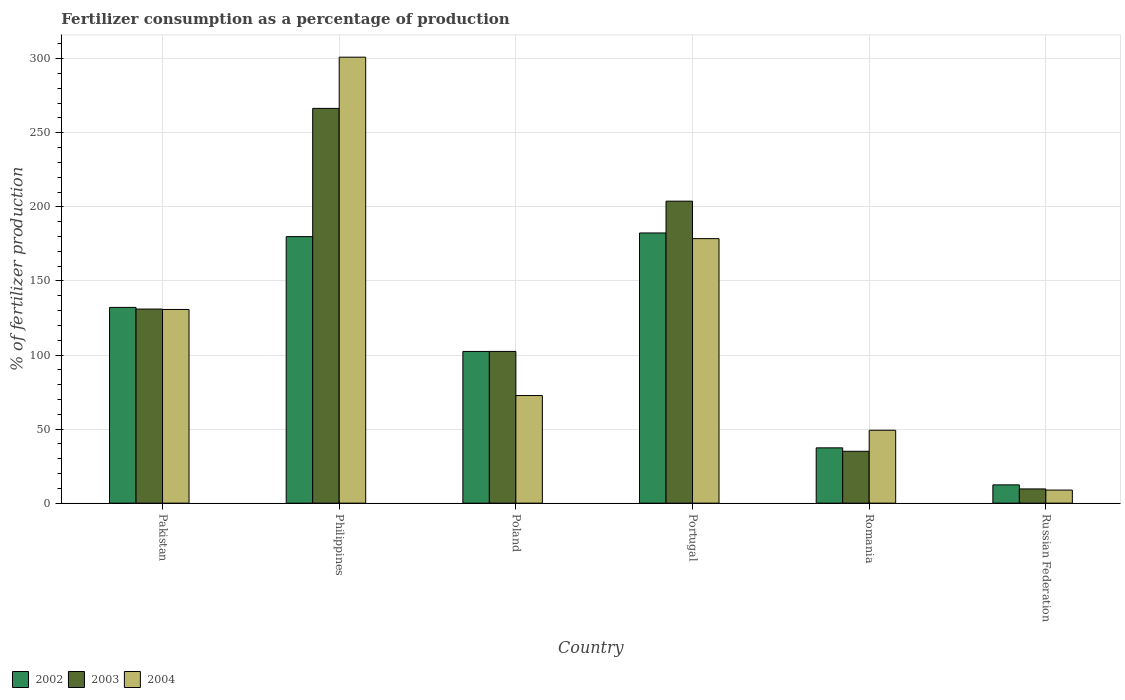How many different coloured bars are there?
Make the answer very short. 3. How many groups of bars are there?
Provide a succinct answer. 6. Are the number of bars per tick equal to the number of legend labels?
Your answer should be compact. Yes. How many bars are there on the 4th tick from the right?
Offer a terse response. 3. What is the label of the 6th group of bars from the left?
Make the answer very short. Russian Federation. What is the percentage of fertilizers consumed in 2002 in Poland?
Your answer should be very brief. 102.4. Across all countries, what is the maximum percentage of fertilizers consumed in 2002?
Keep it short and to the point. 182.38. Across all countries, what is the minimum percentage of fertilizers consumed in 2004?
Provide a short and direct response. 8.83. In which country was the percentage of fertilizers consumed in 2003 maximum?
Provide a short and direct response. Philippines. In which country was the percentage of fertilizers consumed in 2003 minimum?
Your response must be concise. Russian Federation. What is the total percentage of fertilizers consumed in 2004 in the graph?
Give a very brief answer. 740.99. What is the difference between the percentage of fertilizers consumed in 2003 in Pakistan and that in Romania?
Offer a very short reply. 96.01. What is the difference between the percentage of fertilizers consumed in 2002 in Philippines and the percentage of fertilizers consumed in 2004 in Romania?
Your answer should be compact. 130.7. What is the average percentage of fertilizers consumed in 2004 per country?
Provide a short and direct response. 123.5. What is the difference between the percentage of fertilizers consumed of/in 2002 and percentage of fertilizers consumed of/in 2003 in Russian Federation?
Provide a succinct answer. 2.74. What is the ratio of the percentage of fertilizers consumed in 2003 in Philippines to that in Romania?
Keep it short and to the point. 7.61. Is the difference between the percentage of fertilizers consumed in 2002 in Philippines and Russian Federation greater than the difference between the percentage of fertilizers consumed in 2003 in Philippines and Russian Federation?
Make the answer very short. No. What is the difference between the highest and the second highest percentage of fertilizers consumed in 2003?
Provide a short and direct response. 62.63. What is the difference between the highest and the lowest percentage of fertilizers consumed in 2004?
Provide a succinct answer. 292.21. In how many countries, is the percentage of fertilizers consumed in 2002 greater than the average percentage of fertilizers consumed in 2002 taken over all countries?
Your answer should be very brief. 3. Is it the case that in every country, the sum of the percentage of fertilizers consumed in 2003 and percentage of fertilizers consumed in 2002 is greater than the percentage of fertilizers consumed in 2004?
Provide a short and direct response. Yes. What is the difference between two consecutive major ticks on the Y-axis?
Offer a very short reply. 50. Are the values on the major ticks of Y-axis written in scientific E-notation?
Offer a very short reply. No. Where does the legend appear in the graph?
Make the answer very short. Bottom left. How many legend labels are there?
Make the answer very short. 3. How are the legend labels stacked?
Your answer should be very brief. Horizontal. What is the title of the graph?
Offer a very short reply. Fertilizer consumption as a percentage of production. Does "1965" appear as one of the legend labels in the graph?
Make the answer very short. No. What is the label or title of the Y-axis?
Provide a short and direct response. % of fertilizer production. What is the % of fertilizer production in 2002 in Pakistan?
Provide a short and direct response. 132.13. What is the % of fertilizer production of 2003 in Pakistan?
Give a very brief answer. 131.01. What is the % of fertilizer production of 2004 in Pakistan?
Give a very brief answer. 130.73. What is the % of fertilizer production of 2002 in Philippines?
Your response must be concise. 179.9. What is the % of fertilizer production in 2003 in Philippines?
Your answer should be very brief. 266.48. What is the % of fertilizer production of 2004 in Philippines?
Ensure brevity in your answer.  301.04. What is the % of fertilizer production in 2002 in Poland?
Offer a very short reply. 102.4. What is the % of fertilizer production of 2003 in Poland?
Your answer should be very brief. 102.42. What is the % of fertilizer production in 2004 in Poland?
Provide a short and direct response. 72.64. What is the % of fertilizer production in 2002 in Portugal?
Your answer should be very brief. 182.38. What is the % of fertilizer production in 2003 in Portugal?
Provide a short and direct response. 203.85. What is the % of fertilizer production of 2004 in Portugal?
Provide a short and direct response. 178.55. What is the % of fertilizer production of 2002 in Romania?
Offer a very short reply. 37.32. What is the % of fertilizer production in 2003 in Romania?
Ensure brevity in your answer.  35. What is the % of fertilizer production of 2004 in Romania?
Provide a succinct answer. 49.2. What is the % of fertilizer production of 2002 in Russian Federation?
Provide a short and direct response. 12.34. What is the % of fertilizer production of 2003 in Russian Federation?
Give a very brief answer. 9.6. What is the % of fertilizer production of 2004 in Russian Federation?
Offer a very short reply. 8.83. Across all countries, what is the maximum % of fertilizer production of 2002?
Your answer should be very brief. 182.38. Across all countries, what is the maximum % of fertilizer production in 2003?
Your answer should be very brief. 266.48. Across all countries, what is the maximum % of fertilizer production of 2004?
Your response must be concise. 301.04. Across all countries, what is the minimum % of fertilizer production of 2002?
Your response must be concise. 12.34. Across all countries, what is the minimum % of fertilizer production of 2003?
Your response must be concise. 9.6. Across all countries, what is the minimum % of fertilizer production of 2004?
Keep it short and to the point. 8.83. What is the total % of fertilizer production in 2002 in the graph?
Keep it short and to the point. 646.47. What is the total % of fertilizer production in 2003 in the graph?
Your answer should be very brief. 748.35. What is the total % of fertilizer production of 2004 in the graph?
Make the answer very short. 740.99. What is the difference between the % of fertilizer production in 2002 in Pakistan and that in Philippines?
Offer a very short reply. -47.77. What is the difference between the % of fertilizer production of 2003 in Pakistan and that in Philippines?
Your answer should be compact. -135.47. What is the difference between the % of fertilizer production in 2004 in Pakistan and that in Philippines?
Offer a very short reply. -170.31. What is the difference between the % of fertilizer production in 2002 in Pakistan and that in Poland?
Your answer should be very brief. 29.73. What is the difference between the % of fertilizer production of 2003 in Pakistan and that in Poland?
Ensure brevity in your answer.  28.59. What is the difference between the % of fertilizer production in 2004 in Pakistan and that in Poland?
Keep it short and to the point. 58.1. What is the difference between the % of fertilizer production in 2002 in Pakistan and that in Portugal?
Give a very brief answer. -50.24. What is the difference between the % of fertilizer production in 2003 in Pakistan and that in Portugal?
Ensure brevity in your answer.  -72.84. What is the difference between the % of fertilizer production of 2004 in Pakistan and that in Portugal?
Keep it short and to the point. -47.82. What is the difference between the % of fertilizer production in 2002 in Pakistan and that in Romania?
Your response must be concise. 94.81. What is the difference between the % of fertilizer production of 2003 in Pakistan and that in Romania?
Your answer should be very brief. 96.01. What is the difference between the % of fertilizer production in 2004 in Pakistan and that in Romania?
Your response must be concise. 81.54. What is the difference between the % of fertilizer production in 2002 in Pakistan and that in Russian Federation?
Your answer should be compact. 119.79. What is the difference between the % of fertilizer production in 2003 in Pakistan and that in Russian Federation?
Make the answer very short. 121.41. What is the difference between the % of fertilizer production in 2004 in Pakistan and that in Russian Federation?
Your answer should be very brief. 121.91. What is the difference between the % of fertilizer production of 2002 in Philippines and that in Poland?
Provide a succinct answer. 77.5. What is the difference between the % of fertilizer production of 2003 in Philippines and that in Poland?
Make the answer very short. 164.06. What is the difference between the % of fertilizer production in 2004 in Philippines and that in Poland?
Keep it short and to the point. 228.4. What is the difference between the % of fertilizer production of 2002 in Philippines and that in Portugal?
Your response must be concise. -2.48. What is the difference between the % of fertilizer production of 2003 in Philippines and that in Portugal?
Your response must be concise. 62.63. What is the difference between the % of fertilizer production of 2004 in Philippines and that in Portugal?
Keep it short and to the point. 122.49. What is the difference between the % of fertilizer production in 2002 in Philippines and that in Romania?
Give a very brief answer. 142.58. What is the difference between the % of fertilizer production of 2003 in Philippines and that in Romania?
Your response must be concise. 231.48. What is the difference between the % of fertilizer production of 2004 in Philippines and that in Romania?
Keep it short and to the point. 251.84. What is the difference between the % of fertilizer production of 2002 in Philippines and that in Russian Federation?
Make the answer very short. 167.56. What is the difference between the % of fertilizer production in 2003 in Philippines and that in Russian Federation?
Offer a terse response. 256.88. What is the difference between the % of fertilizer production in 2004 in Philippines and that in Russian Federation?
Provide a short and direct response. 292.21. What is the difference between the % of fertilizer production in 2002 in Poland and that in Portugal?
Provide a succinct answer. -79.97. What is the difference between the % of fertilizer production of 2003 in Poland and that in Portugal?
Your response must be concise. -101.43. What is the difference between the % of fertilizer production of 2004 in Poland and that in Portugal?
Provide a short and direct response. -105.91. What is the difference between the % of fertilizer production of 2002 in Poland and that in Romania?
Make the answer very short. 65.08. What is the difference between the % of fertilizer production in 2003 in Poland and that in Romania?
Offer a very short reply. 67.42. What is the difference between the % of fertilizer production in 2004 in Poland and that in Romania?
Keep it short and to the point. 23.44. What is the difference between the % of fertilizer production of 2002 in Poland and that in Russian Federation?
Provide a succinct answer. 90.06. What is the difference between the % of fertilizer production of 2003 in Poland and that in Russian Federation?
Your answer should be very brief. 92.82. What is the difference between the % of fertilizer production of 2004 in Poland and that in Russian Federation?
Your answer should be very brief. 63.81. What is the difference between the % of fertilizer production of 2002 in Portugal and that in Romania?
Keep it short and to the point. 145.06. What is the difference between the % of fertilizer production in 2003 in Portugal and that in Romania?
Ensure brevity in your answer.  168.85. What is the difference between the % of fertilizer production in 2004 in Portugal and that in Romania?
Give a very brief answer. 129.35. What is the difference between the % of fertilizer production of 2002 in Portugal and that in Russian Federation?
Make the answer very short. 170.04. What is the difference between the % of fertilizer production of 2003 in Portugal and that in Russian Federation?
Keep it short and to the point. 194.25. What is the difference between the % of fertilizer production of 2004 in Portugal and that in Russian Federation?
Ensure brevity in your answer.  169.72. What is the difference between the % of fertilizer production of 2002 in Romania and that in Russian Federation?
Ensure brevity in your answer.  24.98. What is the difference between the % of fertilizer production of 2003 in Romania and that in Russian Federation?
Provide a short and direct response. 25.4. What is the difference between the % of fertilizer production of 2004 in Romania and that in Russian Federation?
Provide a short and direct response. 40.37. What is the difference between the % of fertilizer production in 2002 in Pakistan and the % of fertilizer production in 2003 in Philippines?
Provide a short and direct response. -134.34. What is the difference between the % of fertilizer production of 2002 in Pakistan and the % of fertilizer production of 2004 in Philippines?
Your answer should be very brief. -168.91. What is the difference between the % of fertilizer production of 2003 in Pakistan and the % of fertilizer production of 2004 in Philippines?
Provide a short and direct response. -170.03. What is the difference between the % of fertilizer production in 2002 in Pakistan and the % of fertilizer production in 2003 in Poland?
Keep it short and to the point. 29.71. What is the difference between the % of fertilizer production of 2002 in Pakistan and the % of fertilizer production of 2004 in Poland?
Offer a very short reply. 59.5. What is the difference between the % of fertilizer production of 2003 in Pakistan and the % of fertilizer production of 2004 in Poland?
Keep it short and to the point. 58.37. What is the difference between the % of fertilizer production of 2002 in Pakistan and the % of fertilizer production of 2003 in Portugal?
Offer a terse response. -71.71. What is the difference between the % of fertilizer production in 2002 in Pakistan and the % of fertilizer production in 2004 in Portugal?
Your response must be concise. -46.42. What is the difference between the % of fertilizer production in 2003 in Pakistan and the % of fertilizer production in 2004 in Portugal?
Offer a very short reply. -47.54. What is the difference between the % of fertilizer production in 2002 in Pakistan and the % of fertilizer production in 2003 in Romania?
Your answer should be compact. 97.13. What is the difference between the % of fertilizer production in 2002 in Pakistan and the % of fertilizer production in 2004 in Romania?
Give a very brief answer. 82.94. What is the difference between the % of fertilizer production of 2003 in Pakistan and the % of fertilizer production of 2004 in Romania?
Give a very brief answer. 81.81. What is the difference between the % of fertilizer production in 2002 in Pakistan and the % of fertilizer production in 2003 in Russian Federation?
Offer a very short reply. 122.54. What is the difference between the % of fertilizer production of 2002 in Pakistan and the % of fertilizer production of 2004 in Russian Federation?
Provide a succinct answer. 123.3. What is the difference between the % of fertilizer production in 2003 in Pakistan and the % of fertilizer production in 2004 in Russian Federation?
Your answer should be compact. 122.18. What is the difference between the % of fertilizer production in 2002 in Philippines and the % of fertilizer production in 2003 in Poland?
Offer a very short reply. 77.48. What is the difference between the % of fertilizer production in 2002 in Philippines and the % of fertilizer production in 2004 in Poland?
Your response must be concise. 107.26. What is the difference between the % of fertilizer production of 2003 in Philippines and the % of fertilizer production of 2004 in Poland?
Make the answer very short. 193.84. What is the difference between the % of fertilizer production in 2002 in Philippines and the % of fertilizer production in 2003 in Portugal?
Offer a terse response. -23.95. What is the difference between the % of fertilizer production in 2002 in Philippines and the % of fertilizer production in 2004 in Portugal?
Provide a succinct answer. 1.35. What is the difference between the % of fertilizer production of 2003 in Philippines and the % of fertilizer production of 2004 in Portugal?
Keep it short and to the point. 87.93. What is the difference between the % of fertilizer production in 2002 in Philippines and the % of fertilizer production in 2003 in Romania?
Your answer should be compact. 144.9. What is the difference between the % of fertilizer production of 2002 in Philippines and the % of fertilizer production of 2004 in Romania?
Offer a terse response. 130.7. What is the difference between the % of fertilizer production in 2003 in Philippines and the % of fertilizer production in 2004 in Romania?
Make the answer very short. 217.28. What is the difference between the % of fertilizer production in 2002 in Philippines and the % of fertilizer production in 2003 in Russian Federation?
Ensure brevity in your answer.  170.3. What is the difference between the % of fertilizer production in 2002 in Philippines and the % of fertilizer production in 2004 in Russian Federation?
Provide a short and direct response. 171.07. What is the difference between the % of fertilizer production in 2003 in Philippines and the % of fertilizer production in 2004 in Russian Federation?
Your answer should be compact. 257.65. What is the difference between the % of fertilizer production in 2002 in Poland and the % of fertilizer production in 2003 in Portugal?
Offer a very short reply. -101.45. What is the difference between the % of fertilizer production of 2002 in Poland and the % of fertilizer production of 2004 in Portugal?
Make the answer very short. -76.15. What is the difference between the % of fertilizer production in 2003 in Poland and the % of fertilizer production in 2004 in Portugal?
Offer a terse response. -76.13. What is the difference between the % of fertilizer production in 2002 in Poland and the % of fertilizer production in 2003 in Romania?
Your response must be concise. 67.4. What is the difference between the % of fertilizer production of 2002 in Poland and the % of fertilizer production of 2004 in Romania?
Keep it short and to the point. 53.2. What is the difference between the % of fertilizer production in 2003 in Poland and the % of fertilizer production in 2004 in Romania?
Provide a short and direct response. 53.22. What is the difference between the % of fertilizer production of 2002 in Poland and the % of fertilizer production of 2003 in Russian Federation?
Your answer should be very brief. 92.81. What is the difference between the % of fertilizer production in 2002 in Poland and the % of fertilizer production in 2004 in Russian Federation?
Offer a very short reply. 93.57. What is the difference between the % of fertilizer production of 2003 in Poland and the % of fertilizer production of 2004 in Russian Federation?
Offer a very short reply. 93.59. What is the difference between the % of fertilizer production in 2002 in Portugal and the % of fertilizer production in 2003 in Romania?
Give a very brief answer. 147.38. What is the difference between the % of fertilizer production of 2002 in Portugal and the % of fertilizer production of 2004 in Romania?
Offer a very short reply. 133.18. What is the difference between the % of fertilizer production in 2003 in Portugal and the % of fertilizer production in 2004 in Romania?
Your response must be concise. 154.65. What is the difference between the % of fertilizer production of 2002 in Portugal and the % of fertilizer production of 2003 in Russian Federation?
Provide a short and direct response. 172.78. What is the difference between the % of fertilizer production in 2002 in Portugal and the % of fertilizer production in 2004 in Russian Federation?
Offer a very short reply. 173.55. What is the difference between the % of fertilizer production of 2003 in Portugal and the % of fertilizer production of 2004 in Russian Federation?
Give a very brief answer. 195.02. What is the difference between the % of fertilizer production in 2002 in Romania and the % of fertilizer production in 2003 in Russian Federation?
Provide a short and direct response. 27.72. What is the difference between the % of fertilizer production in 2002 in Romania and the % of fertilizer production in 2004 in Russian Federation?
Give a very brief answer. 28.49. What is the difference between the % of fertilizer production of 2003 in Romania and the % of fertilizer production of 2004 in Russian Federation?
Offer a very short reply. 26.17. What is the average % of fertilizer production of 2002 per country?
Make the answer very short. 107.75. What is the average % of fertilizer production of 2003 per country?
Ensure brevity in your answer.  124.73. What is the average % of fertilizer production of 2004 per country?
Ensure brevity in your answer.  123.5. What is the difference between the % of fertilizer production of 2002 and % of fertilizer production of 2003 in Pakistan?
Provide a succinct answer. 1.12. What is the difference between the % of fertilizer production of 2002 and % of fertilizer production of 2004 in Pakistan?
Your answer should be very brief. 1.4. What is the difference between the % of fertilizer production in 2003 and % of fertilizer production in 2004 in Pakistan?
Your answer should be very brief. 0.28. What is the difference between the % of fertilizer production of 2002 and % of fertilizer production of 2003 in Philippines?
Offer a very short reply. -86.58. What is the difference between the % of fertilizer production of 2002 and % of fertilizer production of 2004 in Philippines?
Your response must be concise. -121.14. What is the difference between the % of fertilizer production in 2003 and % of fertilizer production in 2004 in Philippines?
Ensure brevity in your answer.  -34.56. What is the difference between the % of fertilizer production of 2002 and % of fertilizer production of 2003 in Poland?
Ensure brevity in your answer.  -0.02. What is the difference between the % of fertilizer production of 2002 and % of fertilizer production of 2004 in Poland?
Your answer should be very brief. 29.77. What is the difference between the % of fertilizer production of 2003 and % of fertilizer production of 2004 in Poland?
Ensure brevity in your answer.  29.78. What is the difference between the % of fertilizer production in 2002 and % of fertilizer production in 2003 in Portugal?
Make the answer very short. -21.47. What is the difference between the % of fertilizer production of 2002 and % of fertilizer production of 2004 in Portugal?
Make the answer very short. 3.83. What is the difference between the % of fertilizer production of 2003 and % of fertilizer production of 2004 in Portugal?
Provide a short and direct response. 25.3. What is the difference between the % of fertilizer production of 2002 and % of fertilizer production of 2003 in Romania?
Your response must be concise. 2.32. What is the difference between the % of fertilizer production of 2002 and % of fertilizer production of 2004 in Romania?
Your answer should be very brief. -11.88. What is the difference between the % of fertilizer production in 2003 and % of fertilizer production in 2004 in Romania?
Your answer should be very brief. -14.2. What is the difference between the % of fertilizer production in 2002 and % of fertilizer production in 2003 in Russian Federation?
Provide a short and direct response. 2.74. What is the difference between the % of fertilizer production in 2002 and % of fertilizer production in 2004 in Russian Federation?
Provide a succinct answer. 3.51. What is the difference between the % of fertilizer production in 2003 and % of fertilizer production in 2004 in Russian Federation?
Provide a short and direct response. 0.77. What is the ratio of the % of fertilizer production in 2002 in Pakistan to that in Philippines?
Make the answer very short. 0.73. What is the ratio of the % of fertilizer production in 2003 in Pakistan to that in Philippines?
Make the answer very short. 0.49. What is the ratio of the % of fertilizer production of 2004 in Pakistan to that in Philippines?
Your answer should be very brief. 0.43. What is the ratio of the % of fertilizer production in 2002 in Pakistan to that in Poland?
Keep it short and to the point. 1.29. What is the ratio of the % of fertilizer production of 2003 in Pakistan to that in Poland?
Offer a terse response. 1.28. What is the ratio of the % of fertilizer production of 2004 in Pakistan to that in Poland?
Your response must be concise. 1.8. What is the ratio of the % of fertilizer production in 2002 in Pakistan to that in Portugal?
Make the answer very short. 0.72. What is the ratio of the % of fertilizer production in 2003 in Pakistan to that in Portugal?
Keep it short and to the point. 0.64. What is the ratio of the % of fertilizer production in 2004 in Pakistan to that in Portugal?
Your answer should be compact. 0.73. What is the ratio of the % of fertilizer production of 2002 in Pakistan to that in Romania?
Keep it short and to the point. 3.54. What is the ratio of the % of fertilizer production of 2003 in Pakistan to that in Romania?
Provide a short and direct response. 3.74. What is the ratio of the % of fertilizer production in 2004 in Pakistan to that in Romania?
Provide a succinct answer. 2.66. What is the ratio of the % of fertilizer production in 2002 in Pakistan to that in Russian Federation?
Make the answer very short. 10.71. What is the ratio of the % of fertilizer production of 2003 in Pakistan to that in Russian Federation?
Your response must be concise. 13.65. What is the ratio of the % of fertilizer production in 2004 in Pakistan to that in Russian Federation?
Your answer should be compact. 14.81. What is the ratio of the % of fertilizer production of 2002 in Philippines to that in Poland?
Offer a very short reply. 1.76. What is the ratio of the % of fertilizer production of 2003 in Philippines to that in Poland?
Offer a very short reply. 2.6. What is the ratio of the % of fertilizer production in 2004 in Philippines to that in Poland?
Provide a succinct answer. 4.14. What is the ratio of the % of fertilizer production of 2002 in Philippines to that in Portugal?
Keep it short and to the point. 0.99. What is the ratio of the % of fertilizer production in 2003 in Philippines to that in Portugal?
Offer a terse response. 1.31. What is the ratio of the % of fertilizer production of 2004 in Philippines to that in Portugal?
Offer a very short reply. 1.69. What is the ratio of the % of fertilizer production in 2002 in Philippines to that in Romania?
Keep it short and to the point. 4.82. What is the ratio of the % of fertilizer production in 2003 in Philippines to that in Romania?
Your answer should be very brief. 7.61. What is the ratio of the % of fertilizer production in 2004 in Philippines to that in Romania?
Ensure brevity in your answer.  6.12. What is the ratio of the % of fertilizer production of 2002 in Philippines to that in Russian Federation?
Give a very brief answer. 14.58. What is the ratio of the % of fertilizer production in 2003 in Philippines to that in Russian Federation?
Keep it short and to the point. 27.77. What is the ratio of the % of fertilizer production in 2004 in Philippines to that in Russian Federation?
Offer a terse response. 34.09. What is the ratio of the % of fertilizer production of 2002 in Poland to that in Portugal?
Give a very brief answer. 0.56. What is the ratio of the % of fertilizer production of 2003 in Poland to that in Portugal?
Offer a very short reply. 0.5. What is the ratio of the % of fertilizer production in 2004 in Poland to that in Portugal?
Ensure brevity in your answer.  0.41. What is the ratio of the % of fertilizer production in 2002 in Poland to that in Romania?
Keep it short and to the point. 2.74. What is the ratio of the % of fertilizer production in 2003 in Poland to that in Romania?
Provide a succinct answer. 2.93. What is the ratio of the % of fertilizer production of 2004 in Poland to that in Romania?
Your answer should be very brief. 1.48. What is the ratio of the % of fertilizer production of 2002 in Poland to that in Russian Federation?
Give a very brief answer. 8.3. What is the ratio of the % of fertilizer production in 2003 in Poland to that in Russian Federation?
Give a very brief answer. 10.67. What is the ratio of the % of fertilizer production in 2004 in Poland to that in Russian Federation?
Your answer should be compact. 8.23. What is the ratio of the % of fertilizer production in 2002 in Portugal to that in Romania?
Offer a very short reply. 4.89. What is the ratio of the % of fertilizer production in 2003 in Portugal to that in Romania?
Provide a short and direct response. 5.82. What is the ratio of the % of fertilizer production of 2004 in Portugal to that in Romania?
Your answer should be compact. 3.63. What is the ratio of the % of fertilizer production of 2002 in Portugal to that in Russian Federation?
Your answer should be very brief. 14.78. What is the ratio of the % of fertilizer production of 2003 in Portugal to that in Russian Federation?
Offer a very short reply. 21.24. What is the ratio of the % of fertilizer production in 2004 in Portugal to that in Russian Federation?
Make the answer very short. 20.22. What is the ratio of the % of fertilizer production in 2002 in Romania to that in Russian Federation?
Your answer should be compact. 3.02. What is the ratio of the % of fertilizer production of 2003 in Romania to that in Russian Federation?
Your answer should be very brief. 3.65. What is the ratio of the % of fertilizer production in 2004 in Romania to that in Russian Federation?
Give a very brief answer. 5.57. What is the difference between the highest and the second highest % of fertilizer production in 2002?
Make the answer very short. 2.48. What is the difference between the highest and the second highest % of fertilizer production of 2003?
Keep it short and to the point. 62.63. What is the difference between the highest and the second highest % of fertilizer production in 2004?
Keep it short and to the point. 122.49. What is the difference between the highest and the lowest % of fertilizer production of 2002?
Your answer should be very brief. 170.04. What is the difference between the highest and the lowest % of fertilizer production in 2003?
Provide a succinct answer. 256.88. What is the difference between the highest and the lowest % of fertilizer production of 2004?
Make the answer very short. 292.21. 